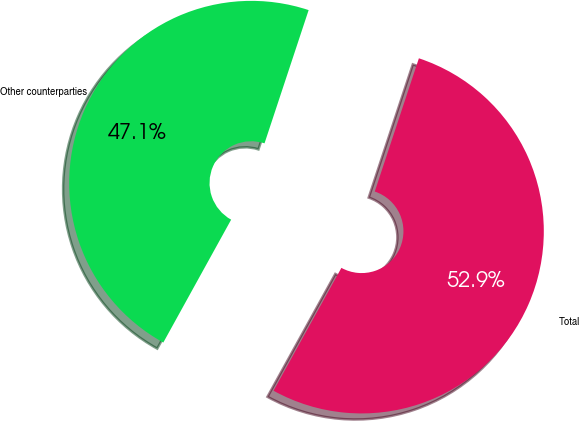Convert chart to OTSL. <chart><loc_0><loc_0><loc_500><loc_500><pie_chart><fcel>Other counterparties<fcel>Total<nl><fcel>47.06%<fcel>52.94%<nl></chart> 